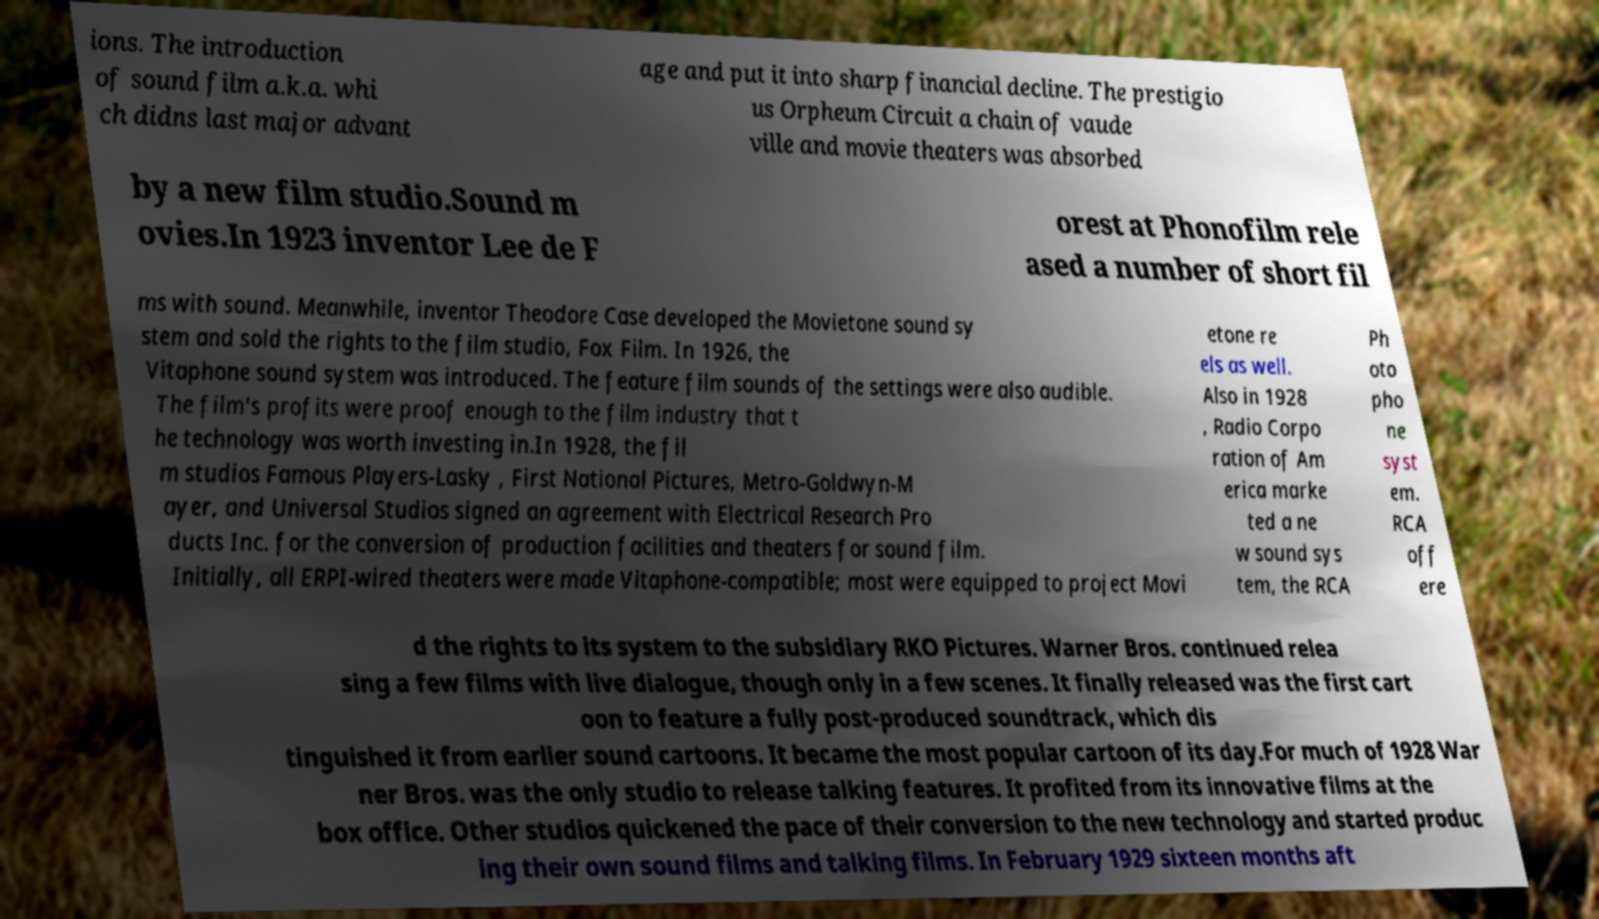Could you extract and type out the text from this image? ions. The introduction of sound film a.k.a. whi ch didns last major advant age and put it into sharp financial decline. The prestigio us Orpheum Circuit a chain of vaude ville and movie theaters was absorbed by a new film studio.Sound m ovies.In 1923 inventor Lee de F orest at Phonofilm rele ased a number of short fil ms with sound. Meanwhile, inventor Theodore Case developed the Movietone sound sy stem and sold the rights to the film studio, Fox Film. In 1926, the Vitaphone sound system was introduced. The feature film sounds of the settings were also audible. The film's profits were proof enough to the film industry that t he technology was worth investing in.In 1928, the fil m studios Famous Players-Lasky , First National Pictures, Metro-Goldwyn-M ayer, and Universal Studios signed an agreement with Electrical Research Pro ducts Inc. for the conversion of production facilities and theaters for sound film. Initially, all ERPI-wired theaters were made Vitaphone-compatible; most were equipped to project Movi etone re els as well. Also in 1928 , Radio Corpo ration of Am erica marke ted a ne w sound sys tem, the RCA Ph oto pho ne syst em. RCA off ere d the rights to its system to the subsidiary RKO Pictures. Warner Bros. continued relea sing a few films with live dialogue, though only in a few scenes. It finally released was the first cart oon to feature a fully post-produced soundtrack, which dis tinguished it from earlier sound cartoons. It became the most popular cartoon of its day.For much of 1928 War ner Bros. was the only studio to release talking features. It profited from its innovative films at the box office. Other studios quickened the pace of their conversion to the new technology and started produc ing their own sound films and talking films. In February 1929 sixteen months aft 